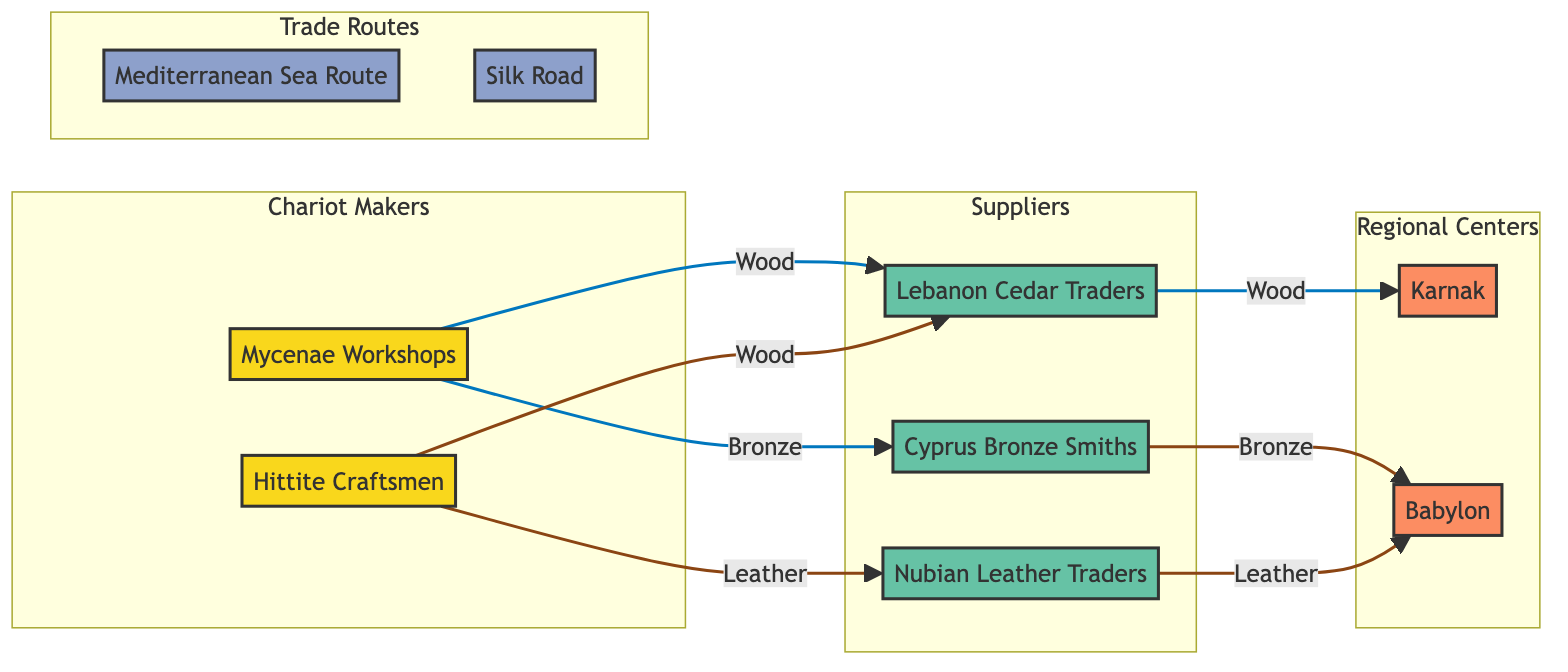What are the names of the chariot makers in the diagram? The diagram lists two chariot makers: "Mycenae Workshops" and "Hittite Craftsmen." These nodes are identified as chariot makers and reflect their respective identities.
Answer: Mycenae Workshops, Hittite Craftsmen How many suppliers are shown in the diagram? The diagram displays three suppliers: "Lebanon Cedar Traders", "Cyprus Bronze Smiths", and "Nubian Leather Traders." Counting the nodes labeled as suppliers gives us this total.
Answer: 3 Which material does the "Cyprus Bronze Smiths" supply? According to the diagram, "Cyprus Bronze Smiths" is labeled as a supplier of "Bronze." This can be confirmed by looking at the node's details in the diagram.
Answer: Bronze What trade route connects the Mycenae Workshops with the Lebanon Cedar Traders? The connection between "Mycenae Workshops" and "Lebanon Cedar Traders" is established through the "Mediterranean Sea Route." This link is represented in the diagram.
Answer: Mediterranean Sea Route Which regional center receives leather from the Nubian Leather Traders? The "Nubian Leather Traders" supply leather to the "Babylon" regional center, as indicated by the arrow connecting these two nodes in the diagram.
Answer: Babylon What is the relationship between the Hittite Craftsmen and the suppliers? The "Hittite Craftsmen" are connected to two suppliers: "Lebanon Cedar Traders" for wood and "Nubian Leather Traders" for leather. The connections demonstrate that they receive material from both suppliers.
Answer: Suppliers: Lebanon Cedar Traders, Nubian Leather Traders Which trade route is associated with the trade of wood to Karnak? "Wood" is traded to "Karnak" via the "Mediterranean Sea Route," which is indicated by the directed link between the corresponding nodes.
Answer: Mediterranean Sea Route How many regional centers are there in the diagram? There are two regional centers displayed in the diagram: "Karnak" and "Babylon." Counting the nodes labeled as regional centers gives this total.
Answer: 2 Which chariot maker does not source leather? "Mycenae Workshops" does not source leather, as this is only linked to "Hittite Craftsmen" in the diagram.
Answer: Mycenae Workshops 